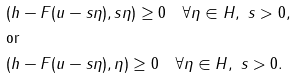Convert formula to latex. <formula><loc_0><loc_0><loc_500><loc_500>& ( h - F ( u - s \eta ) , s \eta ) \geq 0 \quad \forall \eta \in H , \ s > 0 , \\ & \text {or} \\ & ( h - F ( u - s \eta ) , \eta ) \geq 0 \quad \forall \eta \in H , \ s > 0 . \\</formula> 